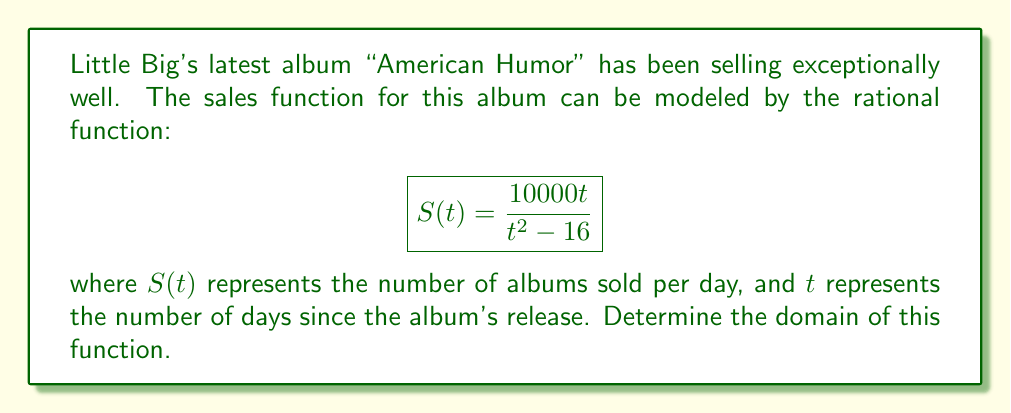Can you answer this question? To find the domain of the rational function, we need to follow these steps:

1) The domain of a rational function includes all real numbers except those that make the denominator equal to zero.

2) In this case, the denominator is $t^2 - 16$. We need to solve the equation:

   $$t^2 - 16 = 0$$

3) Factor the equation:
   
   $$(t+4)(t-4) = 0$$

4) Solve for t:
   
   $t = -4$ or $t = 4$

5) These values of $t$ make the denominator zero, so they must be excluded from the domain.

6) Therefore, the domain is all real numbers except for -4 and 4.

7) In interval notation, this is written as:

   $$(-\infty, -4) \cup (-4, 4) \cup (4, \infty)$$

This means Little Big's album sales function is defined for all days except the 4th day before and after the release.
Answer: $(-\infty, -4) \cup (-4, 4) \cup (4, \infty)$ 